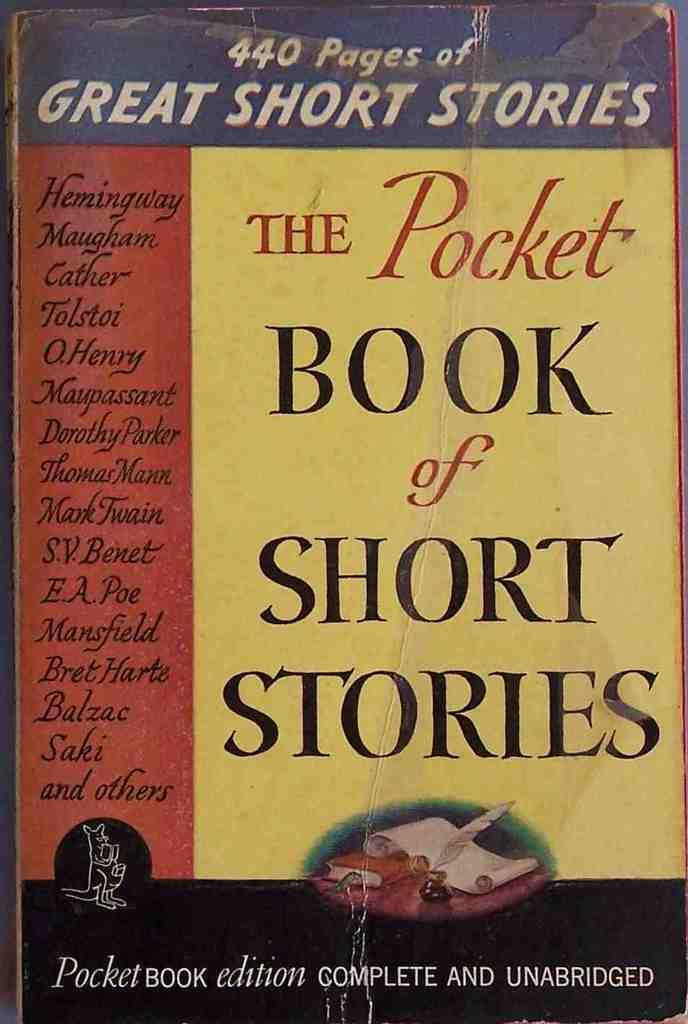<image>
Describe the image concisely. The cover of a book of short stories is worn and stained. 